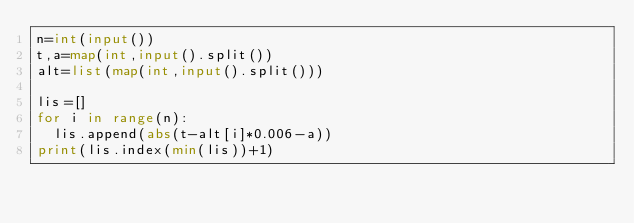<code> <loc_0><loc_0><loc_500><loc_500><_Python_>n=int(input())
t,a=map(int,input().split())
alt=list(map(int,input().split()))

lis=[]
for i in range(n):
  lis.append(abs(t-alt[i]*0.006-a))
print(lis.index(min(lis))+1)</code> 